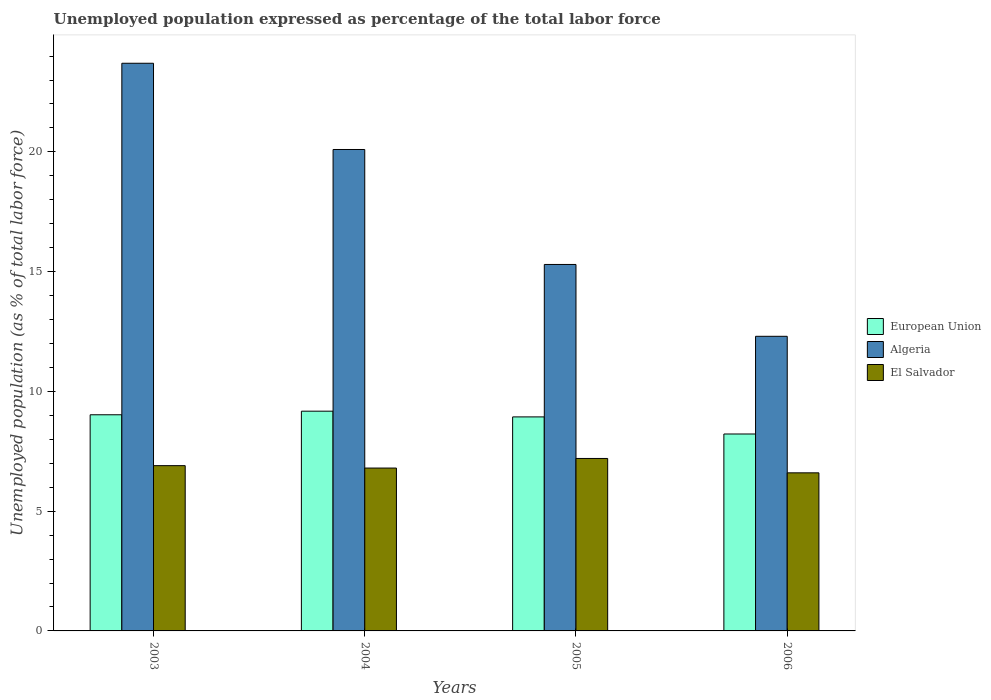How many groups of bars are there?
Ensure brevity in your answer.  4. Are the number of bars per tick equal to the number of legend labels?
Provide a succinct answer. Yes. Are the number of bars on each tick of the X-axis equal?
Your response must be concise. Yes. What is the label of the 4th group of bars from the left?
Keep it short and to the point. 2006. In how many cases, is the number of bars for a given year not equal to the number of legend labels?
Provide a succinct answer. 0. What is the unemployment in in Algeria in 2005?
Your answer should be very brief. 15.3. Across all years, what is the maximum unemployment in in Algeria?
Your answer should be very brief. 23.7. Across all years, what is the minimum unemployment in in Algeria?
Provide a short and direct response. 12.3. What is the total unemployment in in European Union in the graph?
Your answer should be very brief. 35.36. What is the difference between the unemployment in in Algeria in 2003 and that in 2006?
Keep it short and to the point. 11.4. What is the difference between the unemployment in in European Union in 2003 and the unemployment in in El Salvador in 2006?
Offer a terse response. 2.42. What is the average unemployment in in El Salvador per year?
Offer a terse response. 6.88. In the year 2005, what is the difference between the unemployment in in European Union and unemployment in in Algeria?
Provide a short and direct response. -6.36. In how many years, is the unemployment in in El Salvador greater than 2 %?
Provide a succinct answer. 4. What is the ratio of the unemployment in in Algeria in 2004 to that in 2006?
Keep it short and to the point. 1.63. Is the unemployment in in El Salvador in 2004 less than that in 2006?
Provide a short and direct response. No. What is the difference between the highest and the second highest unemployment in in El Salvador?
Offer a very short reply. 0.3. What is the difference between the highest and the lowest unemployment in in Algeria?
Offer a very short reply. 11.4. In how many years, is the unemployment in in El Salvador greater than the average unemployment in in El Salvador taken over all years?
Offer a terse response. 2. Is the sum of the unemployment in in El Salvador in 2003 and 2005 greater than the maximum unemployment in in European Union across all years?
Your answer should be very brief. Yes. What does the 2nd bar from the left in 2005 represents?
Offer a very short reply. Algeria. What does the 1st bar from the right in 2005 represents?
Offer a very short reply. El Salvador. What is the difference between two consecutive major ticks on the Y-axis?
Offer a terse response. 5. Are the values on the major ticks of Y-axis written in scientific E-notation?
Your answer should be compact. No. What is the title of the graph?
Ensure brevity in your answer.  Unemployed population expressed as percentage of the total labor force. Does "Australia" appear as one of the legend labels in the graph?
Give a very brief answer. No. What is the label or title of the X-axis?
Give a very brief answer. Years. What is the label or title of the Y-axis?
Ensure brevity in your answer.  Unemployed population (as % of total labor force). What is the Unemployed population (as % of total labor force) in European Union in 2003?
Ensure brevity in your answer.  9.02. What is the Unemployed population (as % of total labor force) in Algeria in 2003?
Your response must be concise. 23.7. What is the Unemployed population (as % of total labor force) of El Salvador in 2003?
Your answer should be very brief. 6.9. What is the Unemployed population (as % of total labor force) of European Union in 2004?
Give a very brief answer. 9.17. What is the Unemployed population (as % of total labor force) in Algeria in 2004?
Offer a terse response. 20.1. What is the Unemployed population (as % of total labor force) of El Salvador in 2004?
Make the answer very short. 6.8. What is the Unemployed population (as % of total labor force) in European Union in 2005?
Provide a succinct answer. 8.94. What is the Unemployed population (as % of total labor force) in Algeria in 2005?
Give a very brief answer. 15.3. What is the Unemployed population (as % of total labor force) of El Salvador in 2005?
Provide a short and direct response. 7.2. What is the Unemployed population (as % of total labor force) of European Union in 2006?
Your answer should be very brief. 8.22. What is the Unemployed population (as % of total labor force) of Algeria in 2006?
Your answer should be compact. 12.3. What is the Unemployed population (as % of total labor force) in El Salvador in 2006?
Make the answer very short. 6.6. Across all years, what is the maximum Unemployed population (as % of total labor force) of European Union?
Ensure brevity in your answer.  9.17. Across all years, what is the maximum Unemployed population (as % of total labor force) of Algeria?
Your answer should be compact. 23.7. Across all years, what is the maximum Unemployed population (as % of total labor force) in El Salvador?
Your answer should be compact. 7.2. Across all years, what is the minimum Unemployed population (as % of total labor force) in European Union?
Keep it short and to the point. 8.22. Across all years, what is the minimum Unemployed population (as % of total labor force) of Algeria?
Your response must be concise. 12.3. Across all years, what is the minimum Unemployed population (as % of total labor force) in El Salvador?
Provide a short and direct response. 6.6. What is the total Unemployed population (as % of total labor force) in European Union in the graph?
Your answer should be very brief. 35.36. What is the total Unemployed population (as % of total labor force) in Algeria in the graph?
Your answer should be compact. 71.4. What is the difference between the Unemployed population (as % of total labor force) in European Union in 2003 and that in 2004?
Ensure brevity in your answer.  -0.15. What is the difference between the Unemployed population (as % of total labor force) in Algeria in 2003 and that in 2004?
Offer a terse response. 3.6. What is the difference between the Unemployed population (as % of total labor force) of European Union in 2003 and that in 2005?
Keep it short and to the point. 0.09. What is the difference between the Unemployed population (as % of total labor force) in Algeria in 2003 and that in 2005?
Give a very brief answer. 8.4. What is the difference between the Unemployed population (as % of total labor force) of El Salvador in 2003 and that in 2005?
Offer a very short reply. -0.3. What is the difference between the Unemployed population (as % of total labor force) in European Union in 2003 and that in 2006?
Offer a terse response. 0.8. What is the difference between the Unemployed population (as % of total labor force) of Algeria in 2003 and that in 2006?
Your response must be concise. 11.4. What is the difference between the Unemployed population (as % of total labor force) of European Union in 2004 and that in 2005?
Give a very brief answer. 0.24. What is the difference between the Unemployed population (as % of total labor force) of El Salvador in 2004 and that in 2005?
Provide a succinct answer. -0.4. What is the difference between the Unemployed population (as % of total labor force) of European Union in 2004 and that in 2006?
Your response must be concise. 0.95. What is the difference between the Unemployed population (as % of total labor force) of European Union in 2005 and that in 2006?
Ensure brevity in your answer.  0.71. What is the difference between the Unemployed population (as % of total labor force) in European Union in 2003 and the Unemployed population (as % of total labor force) in Algeria in 2004?
Make the answer very short. -11.08. What is the difference between the Unemployed population (as % of total labor force) of European Union in 2003 and the Unemployed population (as % of total labor force) of El Salvador in 2004?
Your response must be concise. 2.22. What is the difference between the Unemployed population (as % of total labor force) in European Union in 2003 and the Unemployed population (as % of total labor force) in Algeria in 2005?
Provide a succinct answer. -6.28. What is the difference between the Unemployed population (as % of total labor force) of European Union in 2003 and the Unemployed population (as % of total labor force) of El Salvador in 2005?
Offer a terse response. 1.82. What is the difference between the Unemployed population (as % of total labor force) in Algeria in 2003 and the Unemployed population (as % of total labor force) in El Salvador in 2005?
Your answer should be compact. 16.5. What is the difference between the Unemployed population (as % of total labor force) in European Union in 2003 and the Unemployed population (as % of total labor force) in Algeria in 2006?
Provide a succinct answer. -3.28. What is the difference between the Unemployed population (as % of total labor force) in European Union in 2003 and the Unemployed population (as % of total labor force) in El Salvador in 2006?
Provide a succinct answer. 2.42. What is the difference between the Unemployed population (as % of total labor force) in European Union in 2004 and the Unemployed population (as % of total labor force) in Algeria in 2005?
Give a very brief answer. -6.13. What is the difference between the Unemployed population (as % of total labor force) of European Union in 2004 and the Unemployed population (as % of total labor force) of El Salvador in 2005?
Make the answer very short. 1.97. What is the difference between the Unemployed population (as % of total labor force) of European Union in 2004 and the Unemployed population (as % of total labor force) of Algeria in 2006?
Your response must be concise. -3.13. What is the difference between the Unemployed population (as % of total labor force) of European Union in 2004 and the Unemployed population (as % of total labor force) of El Salvador in 2006?
Offer a very short reply. 2.57. What is the difference between the Unemployed population (as % of total labor force) in European Union in 2005 and the Unemployed population (as % of total labor force) in Algeria in 2006?
Keep it short and to the point. -3.36. What is the difference between the Unemployed population (as % of total labor force) of European Union in 2005 and the Unemployed population (as % of total labor force) of El Salvador in 2006?
Provide a succinct answer. 2.34. What is the average Unemployed population (as % of total labor force) in European Union per year?
Your answer should be very brief. 8.84. What is the average Unemployed population (as % of total labor force) in Algeria per year?
Your answer should be very brief. 17.85. What is the average Unemployed population (as % of total labor force) in El Salvador per year?
Offer a very short reply. 6.88. In the year 2003, what is the difference between the Unemployed population (as % of total labor force) in European Union and Unemployed population (as % of total labor force) in Algeria?
Keep it short and to the point. -14.68. In the year 2003, what is the difference between the Unemployed population (as % of total labor force) of European Union and Unemployed population (as % of total labor force) of El Salvador?
Your answer should be compact. 2.12. In the year 2003, what is the difference between the Unemployed population (as % of total labor force) of Algeria and Unemployed population (as % of total labor force) of El Salvador?
Keep it short and to the point. 16.8. In the year 2004, what is the difference between the Unemployed population (as % of total labor force) in European Union and Unemployed population (as % of total labor force) in Algeria?
Ensure brevity in your answer.  -10.93. In the year 2004, what is the difference between the Unemployed population (as % of total labor force) in European Union and Unemployed population (as % of total labor force) in El Salvador?
Offer a terse response. 2.37. In the year 2004, what is the difference between the Unemployed population (as % of total labor force) of Algeria and Unemployed population (as % of total labor force) of El Salvador?
Provide a succinct answer. 13.3. In the year 2005, what is the difference between the Unemployed population (as % of total labor force) in European Union and Unemployed population (as % of total labor force) in Algeria?
Provide a succinct answer. -6.36. In the year 2005, what is the difference between the Unemployed population (as % of total labor force) of European Union and Unemployed population (as % of total labor force) of El Salvador?
Ensure brevity in your answer.  1.74. In the year 2006, what is the difference between the Unemployed population (as % of total labor force) of European Union and Unemployed population (as % of total labor force) of Algeria?
Ensure brevity in your answer.  -4.08. In the year 2006, what is the difference between the Unemployed population (as % of total labor force) of European Union and Unemployed population (as % of total labor force) of El Salvador?
Make the answer very short. 1.62. In the year 2006, what is the difference between the Unemployed population (as % of total labor force) of Algeria and Unemployed population (as % of total labor force) of El Salvador?
Your answer should be compact. 5.7. What is the ratio of the Unemployed population (as % of total labor force) in European Union in 2003 to that in 2004?
Ensure brevity in your answer.  0.98. What is the ratio of the Unemployed population (as % of total labor force) in Algeria in 2003 to that in 2004?
Ensure brevity in your answer.  1.18. What is the ratio of the Unemployed population (as % of total labor force) of El Salvador in 2003 to that in 2004?
Keep it short and to the point. 1.01. What is the ratio of the Unemployed population (as % of total labor force) in European Union in 2003 to that in 2005?
Keep it short and to the point. 1.01. What is the ratio of the Unemployed population (as % of total labor force) of Algeria in 2003 to that in 2005?
Offer a terse response. 1.55. What is the ratio of the Unemployed population (as % of total labor force) of European Union in 2003 to that in 2006?
Your answer should be compact. 1.1. What is the ratio of the Unemployed population (as % of total labor force) of Algeria in 2003 to that in 2006?
Your answer should be very brief. 1.93. What is the ratio of the Unemployed population (as % of total labor force) of El Salvador in 2003 to that in 2006?
Provide a succinct answer. 1.05. What is the ratio of the Unemployed population (as % of total labor force) of European Union in 2004 to that in 2005?
Your answer should be compact. 1.03. What is the ratio of the Unemployed population (as % of total labor force) of Algeria in 2004 to that in 2005?
Provide a succinct answer. 1.31. What is the ratio of the Unemployed population (as % of total labor force) of El Salvador in 2004 to that in 2005?
Make the answer very short. 0.94. What is the ratio of the Unemployed population (as % of total labor force) of European Union in 2004 to that in 2006?
Offer a very short reply. 1.12. What is the ratio of the Unemployed population (as % of total labor force) in Algeria in 2004 to that in 2006?
Ensure brevity in your answer.  1.63. What is the ratio of the Unemployed population (as % of total labor force) of El Salvador in 2004 to that in 2006?
Give a very brief answer. 1.03. What is the ratio of the Unemployed population (as % of total labor force) of European Union in 2005 to that in 2006?
Your answer should be very brief. 1.09. What is the ratio of the Unemployed population (as % of total labor force) of Algeria in 2005 to that in 2006?
Provide a succinct answer. 1.24. What is the ratio of the Unemployed population (as % of total labor force) in El Salvador in 2005 to that in 2006?
Provide a short and direct response. 1.09. What is the difference between the highest and the second highest Unemployed population (as % of total labor force) of European Union?
Offer a very short reply. 0.15. What is the difference between the highest and the lowest Unemployed population (as % of total labor force) in European Union?
Provide a short and direct response. 0.95. What is the difference between the highest and the lowest Unemployed population (as % of total labor force) of Algeria?
Provide a short and direct response. 11.4. What is the difference between the highest and the lowest Unemployed population (as % of total labor force) in El Salvador?
Make the answer very short. 0.6. 